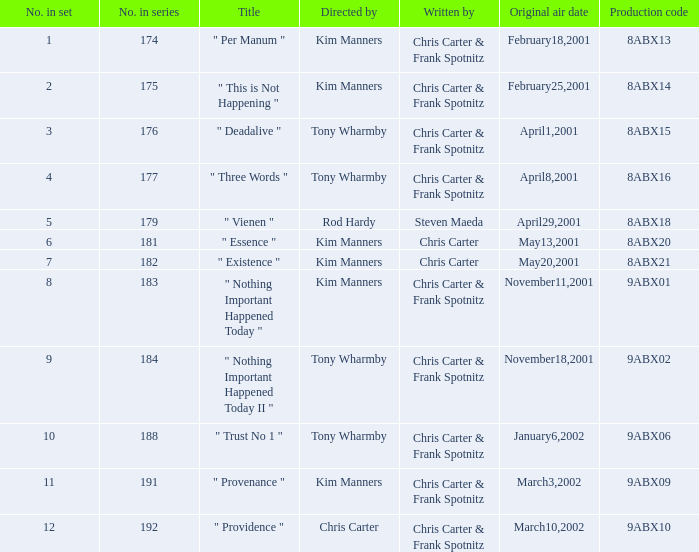What is the episode number that has production code 8abx15? 176.0. Parse the full table. {'header': ['No. in set', 'No. in series', 'Title', 'Directed by', 'Written by', 'Original air date', 'Production code'], 'rows': [['1', '174', '" Per Manum "', 'Kim Manners', 'Chris Carter & Frank Spotnitz', 'February18,2001', '8ABX13'], ['2', '175', '" This is Not Happening "', 'Kim Manners', 'Chris Carter & Frank Spotnitz', 'February25,2001', '8ABX14'], ['3', '176', '" Deadalive "', 'Tony Wharmby', 'Chris Carter & Frank Spotnitz', 'April1,2001', '8ABX15'], ['4', '177', '" Three Words "', 'Tony Wharmby', 'Chris Carter & Frank Spotnitz', 'April8,2001', '8ABX16'], ['5', '179', '" Vienen "', 'Rod Hardy', 'Steven Maeda', 'April29,2001', '8ABX18'], ['6', '181', '" Essence "', 'Kim Manners', 'Chris Carter', 'May13,2001', '8ABX20'], ['7', '182', '" Existence "', 'Kim Manners', 'Chris Carter', 'May20,2001', '8ABX21'], ['8', '183', '" Nothing Important Happened Today "', 'Kim Manners', 'Chris Carter & Frank Spotnitz', 'November11,2001', '9ABX01'], ['9', '184', '" Nothing Important Happened Today II "', 'Tony Wharmby', 'Chris Carter & Frank Spotnitz', 'November18,2001', '9ABX02'], ['10', '188', '" Trust No 1 "', 'Tony Wharmby', 'Chris Carter & Frank Spotnitz', 'January6,2002', '9ABX06'], ['11', '191', '" Provenance "', 'Kim Manners', 'Chris Carter & Frank Spotnitz', 'March3,2002', '9ABX09'], ['12', '192', '" Providence "', 'Chris Carter', 'Chris Carter & Frank Spotnitz', 'March10,2002', '9ABX10']]} 